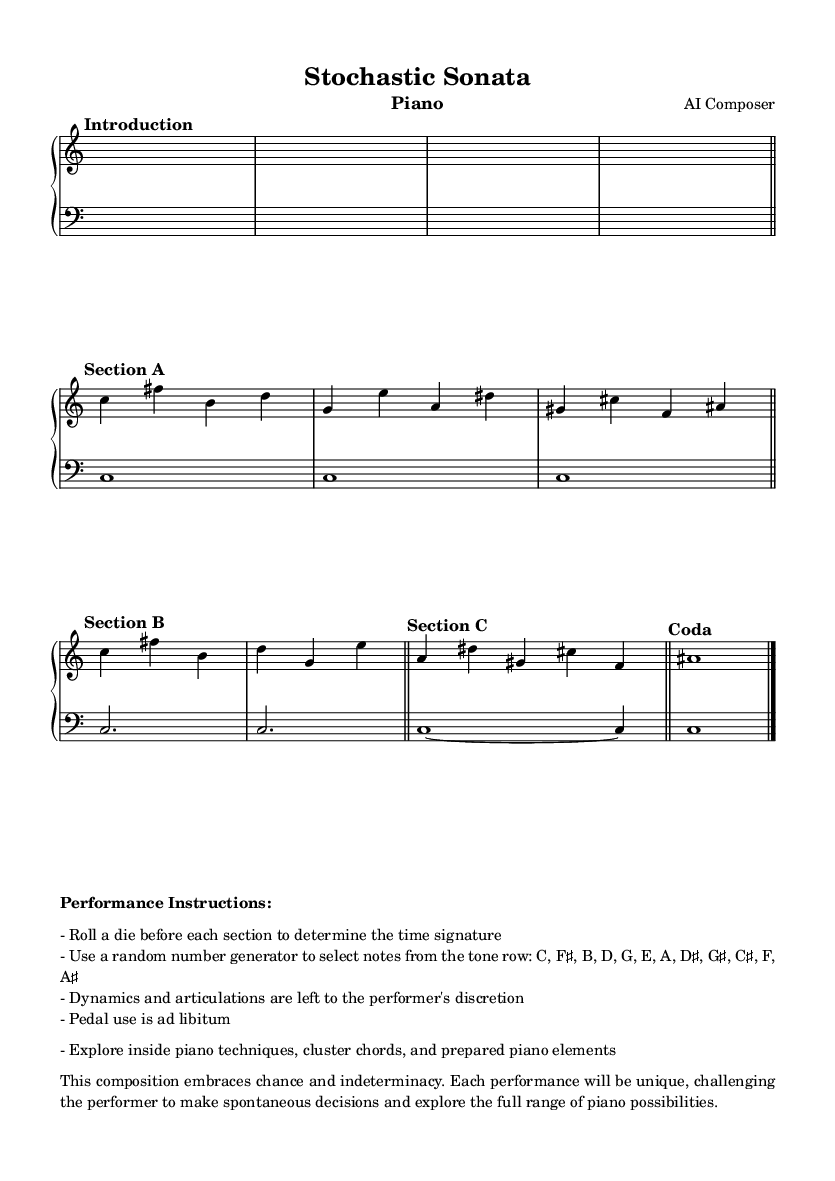What is the time signature of Section A? The time signature of Section A is 4/4, which can be identified just before the music notes in that section.
Answer: 4/4 What is the key signature of the piece? The piece does not have an explicit key signature indicated in the sheet music, which typically means it is in C major (no sharps or flats) or uses a modal approach.
Answer: C major How many bars are in Section B? Section B consists of two measures as indicated by the bar lines following the music notes.
Answer: 2 What dynamics are indicated in the performance instructions? The performance instructions state that dynamics are left to the performer's discretion, indicating no specific dynamics are prescribed in the sheet music.
Answer: Discretion What are the note selections derived from? The note selections are to be made from a specific tone row provided in the performance instructions, which includes C, F♯, B, D, G, E, A, D♯, G♯, C♯, F, A♯.
Answer: Tone row How does the composer suggest the use of chance in the performance? The composer suggests using a die to determine the time signature and a random number generator to select notes, emphasizing spontaneity and unpredictability in performance.
Answer: Chance operations What unique techniques does the composer encourage? The composer encourages exploring inside piano techniques, cluster chords, and prepared piano elements, allowing for creative interpretation.
Answer: Inside piano techniques, cluster chords, prepared piano 